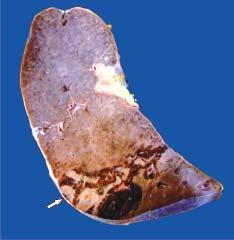what is seen with base resting under the capsule, while the margin is congested?
Answer the question using a single word or phrase. Wedge-shaped shrunken area of pale colour 